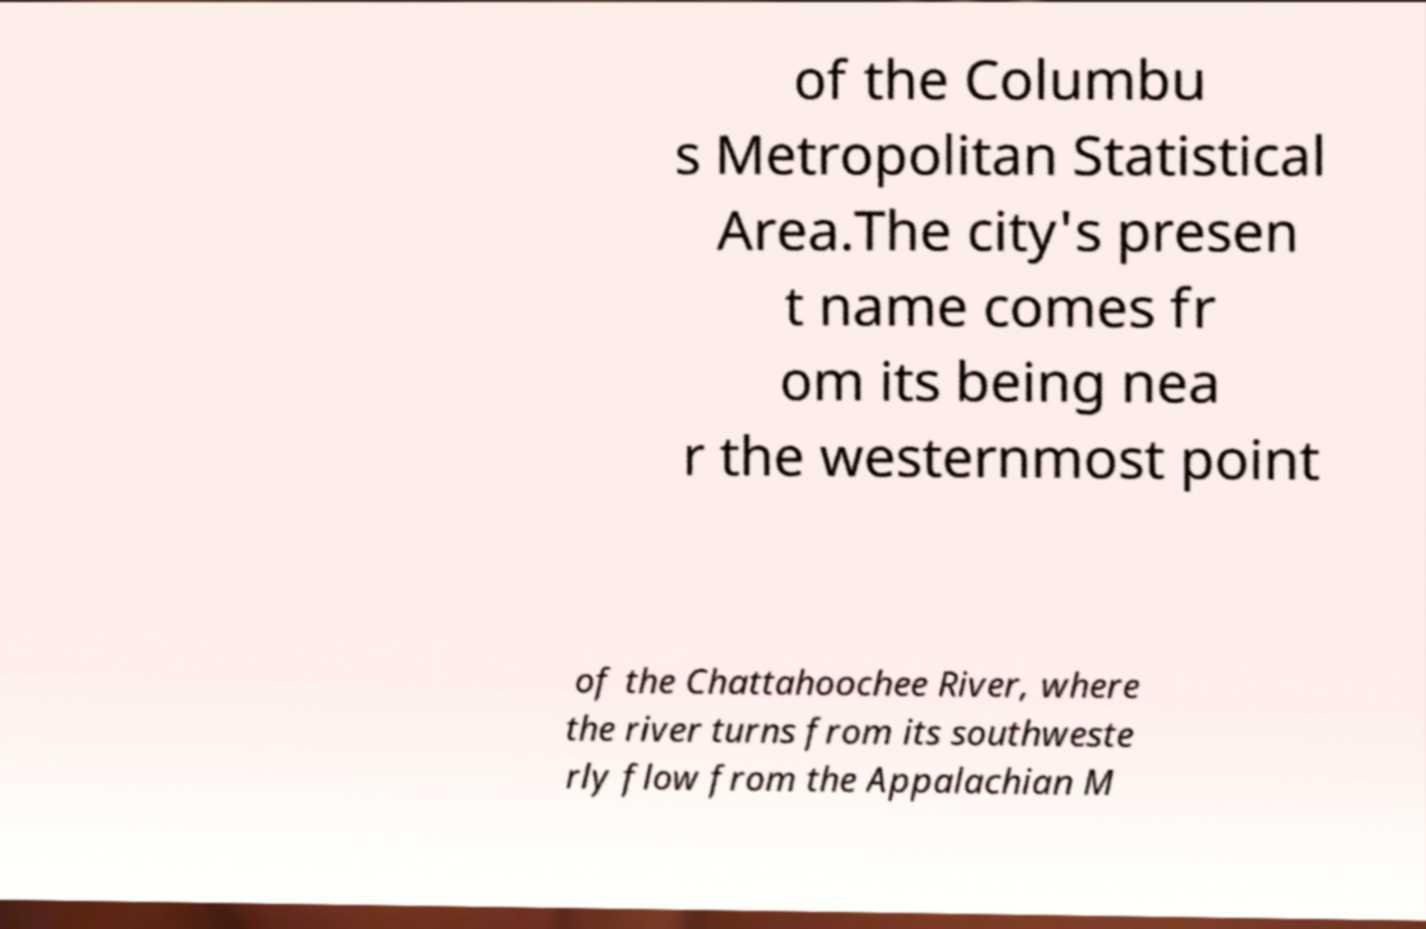Can you read and provide the text displayed in the image?This photo seems to have some interesting text. Can you extract and type it out for me? of the Columbu s Metropolitan Statistical Area.The city's presen t name comes fr om its being nea r the westernmost point of the Chattahoochee River, where the river turns from its southweste rly flow from the Appalachian M 